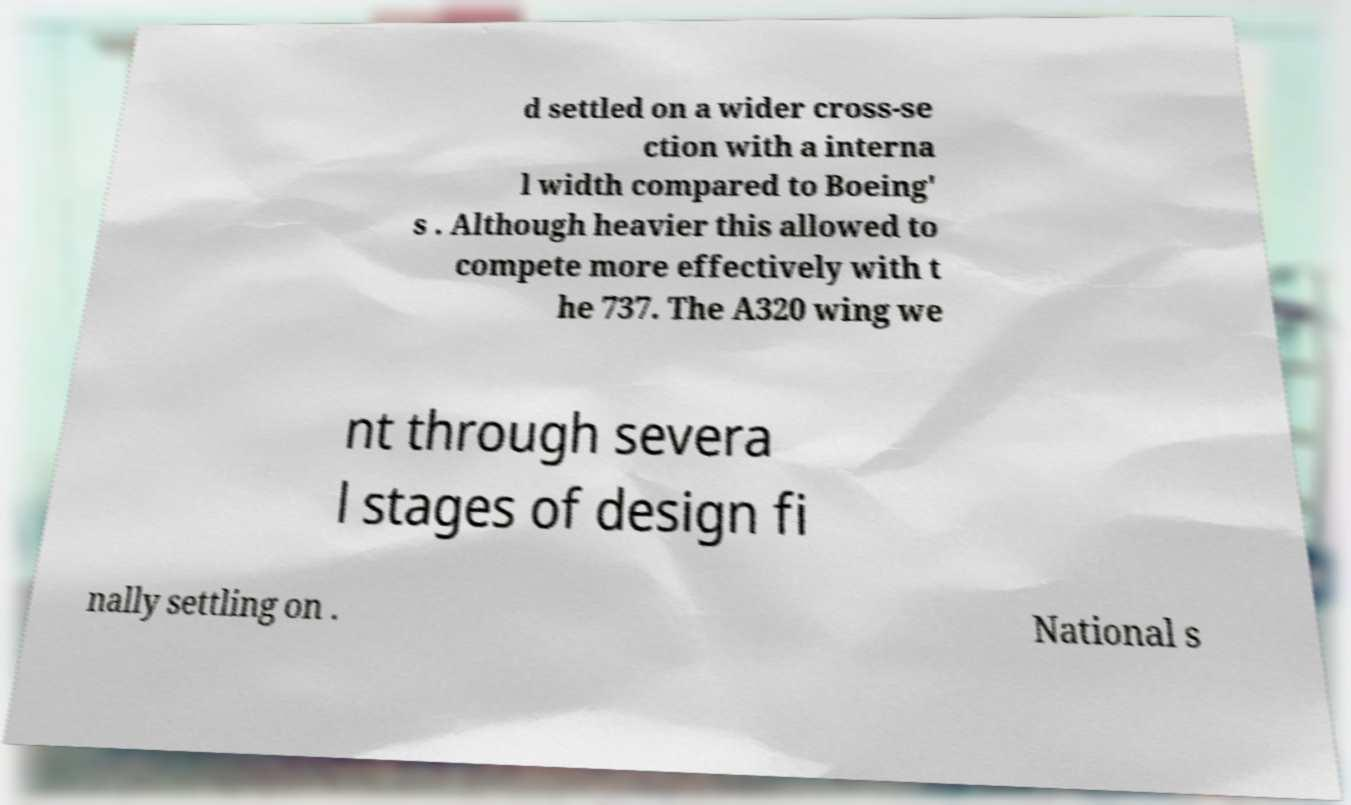For documentation purposes, I need the text within this image transcribed. Could you provide that? d settled on a wider cross-se ction with a interna l width compared to Boeing' s . Although heavier this allowed to compete more effectively with t he 737. The A320 wing we nt through severa l stages of design fi nally settling on . National s 